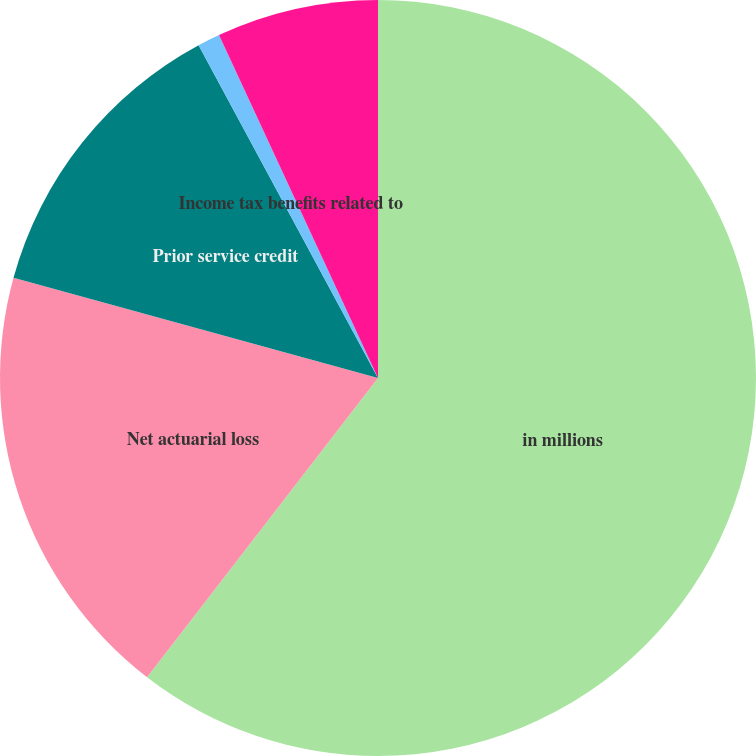<chart> <loc_0><loc_0><loc_500><loc_500><pie_chart><fcel>in millions<fcel>Net actuarial loss<fcel>Prior service credit<fcel>Income tax benefits related to<fcel>Unamortized benefit plan costs<nl><fcel>60.46%<fcel>18.81%<fcel>12.86%<fcel>0.96%<fcel>6.91%<nl></chart> 